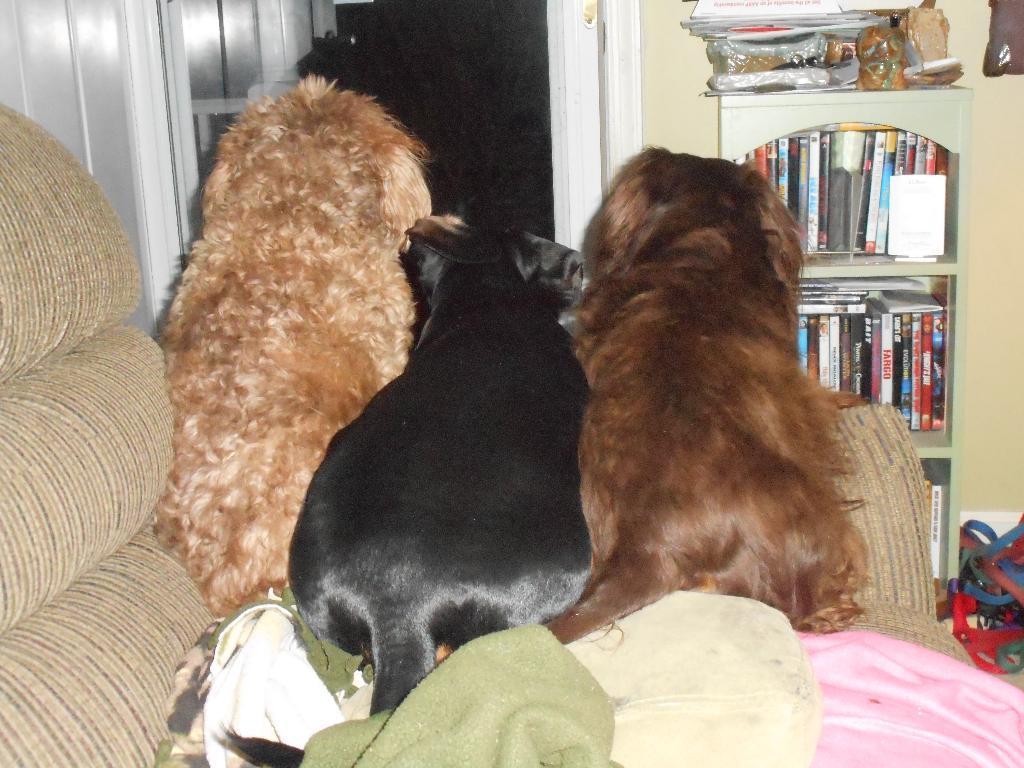Can you describe this image briefly? In this image we can see three dogs on the sofa, there is a cupboard with some books, on the cupboard we can see some objects, also we can see a door and the wall, there are some wires on the floor. 